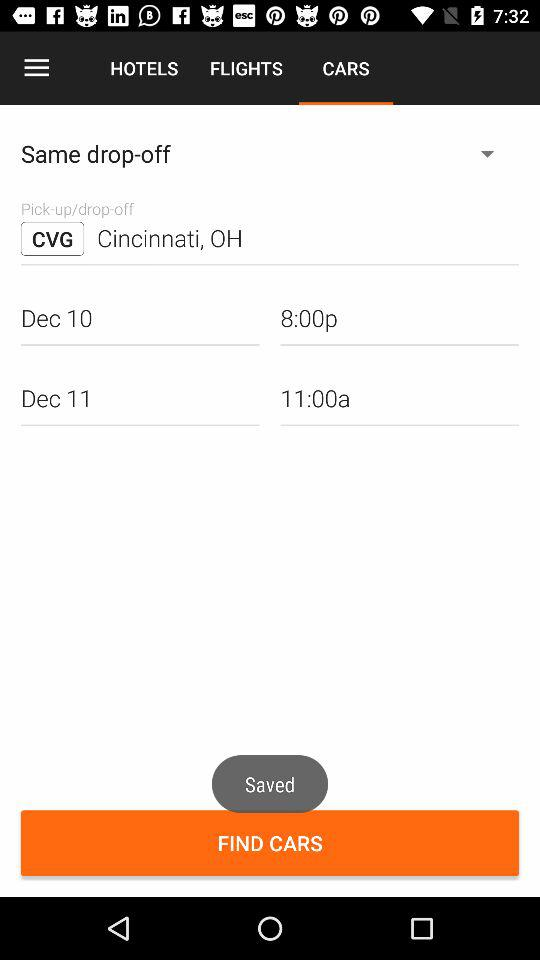What is the pick-up date? The pick-up date is December 10. 